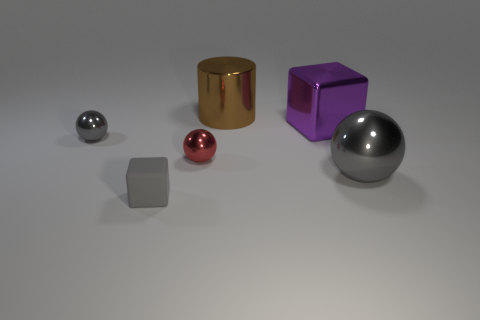Subtract all gray balls. How many were subtracted if there are1gray balls left? 1 Add 2 brown metallic things. How many objects exist? 8 Subtract all cubes. How many objects are left? 4 Add 1 matte cubes. How many matte cubes are left? 2 Add 5 gray rubber cubes. How many gray rubber cubes exist? 6 Subtract 1 purple cubes. How many objects are left? 5 Subtract all big red shiny cylinders. Subtract all brown metallic cylinders. How many objects are left? 5 